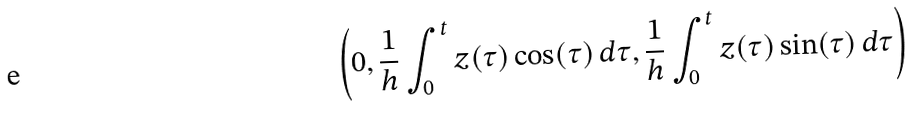Convert formula to latex. <formula><loc_0><loc_0><loc_500><loc_500>\left ( 0 , \frac { 1 } { h } \int _ { 0 } ^ { t } z ( \tau ) \cos ( \tau ) \, d \tau , \frac { 1 } { h } \int _ { 0 } ^ { t } z ( \tau ) \sin ( \tau ) \, d \tau \right )</formula> 